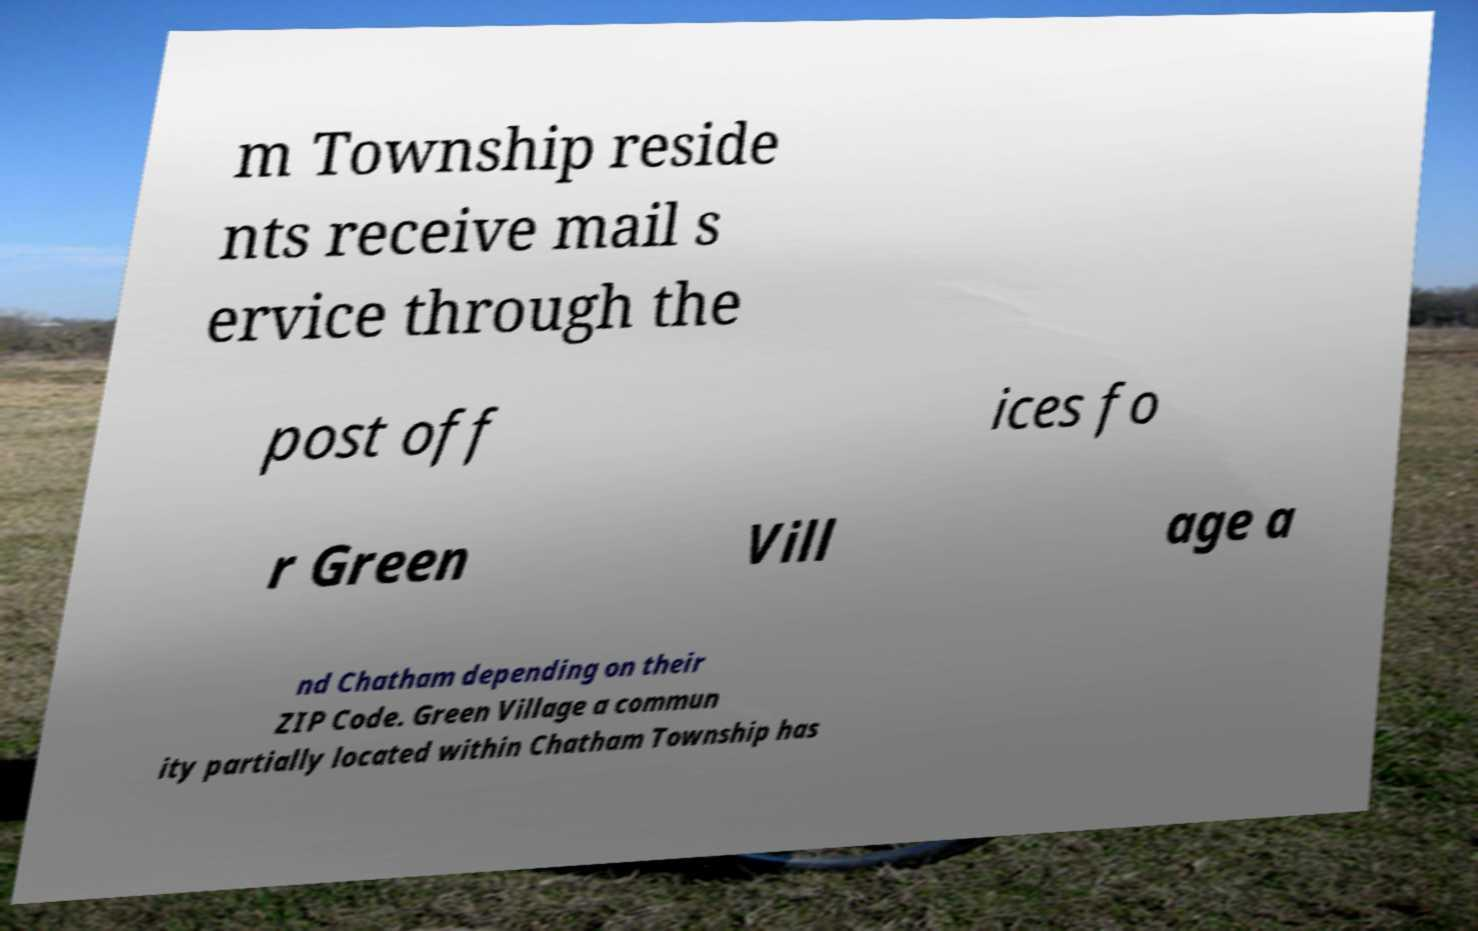Can you accurately transcribe the text from the provided image for me? m Township reside nts receive mail s ervice through the post off ices fo r Green Vill age a nd Chatham depending on their ZIP Code. Green Village a commun ity partially located within Chatham Township has 